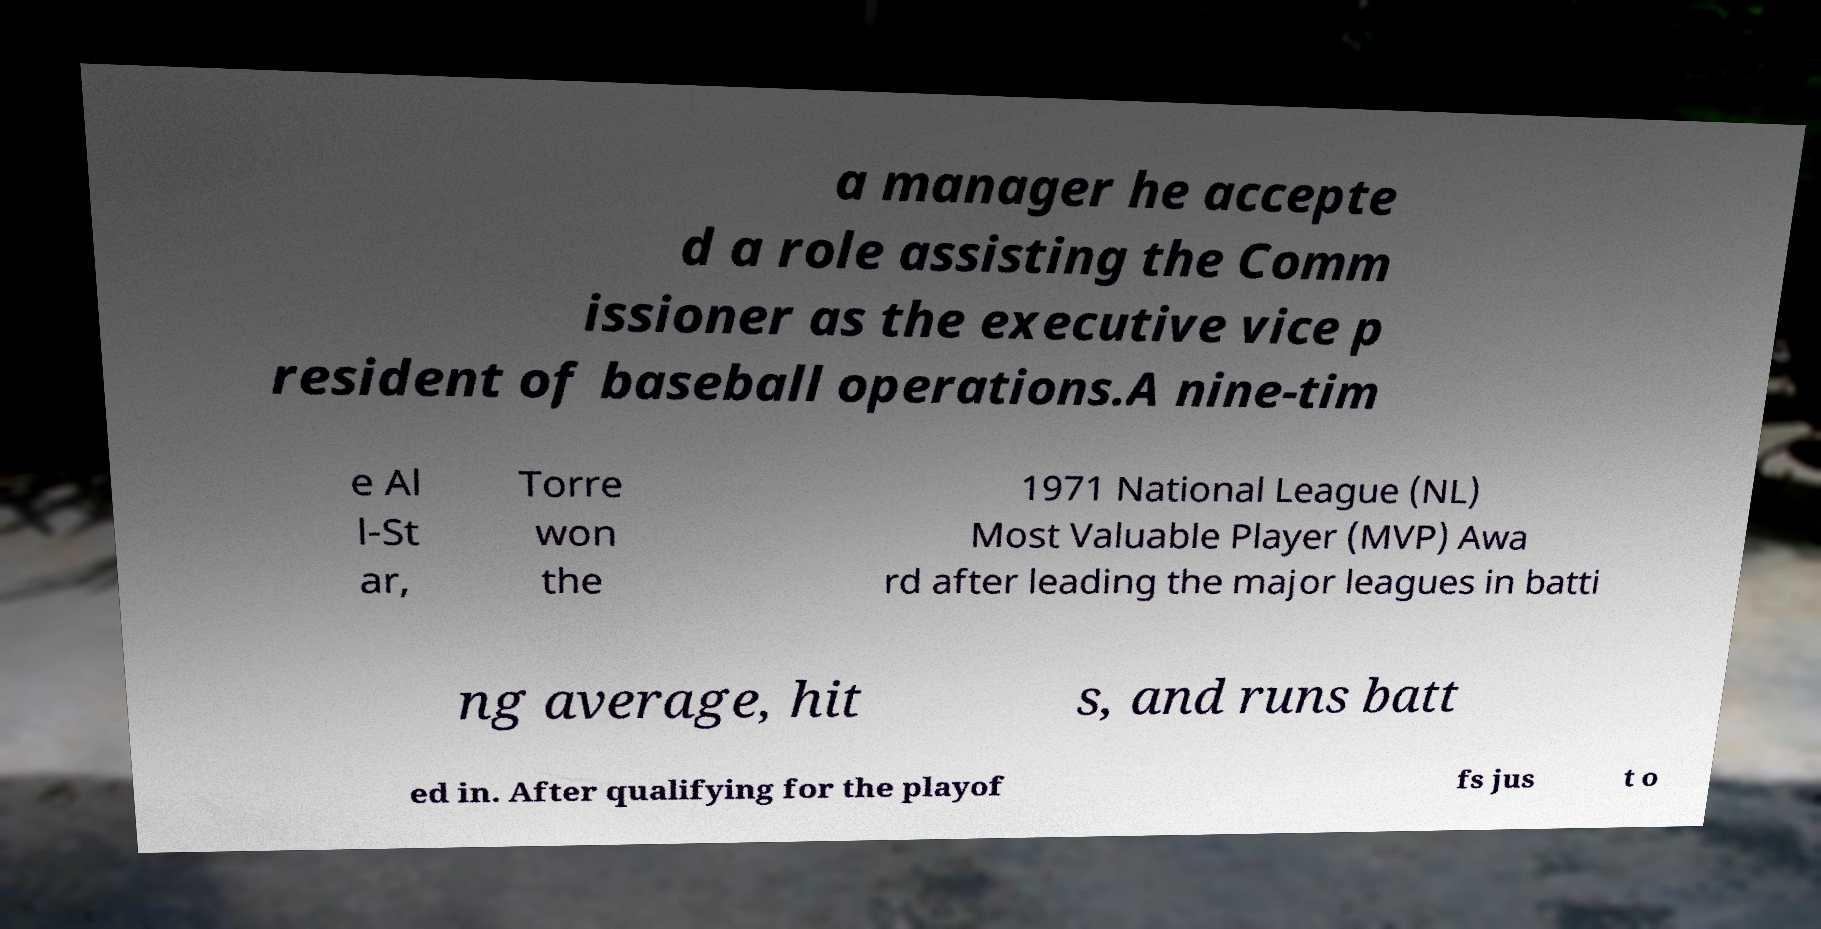Could you extract and type out the text from this image? a manager he accepte d a role assisting the Comm issioner as the executive vice p resident of baseball operations.A nine-tim e Al l-St ar, Torre won the 1971 National League (NL) Most Valuable Player (MVP) Awa rd after leading the major leagues in batti ng average, hit s, and runs batt ed in. After qualifying for the playof fs jus t o 